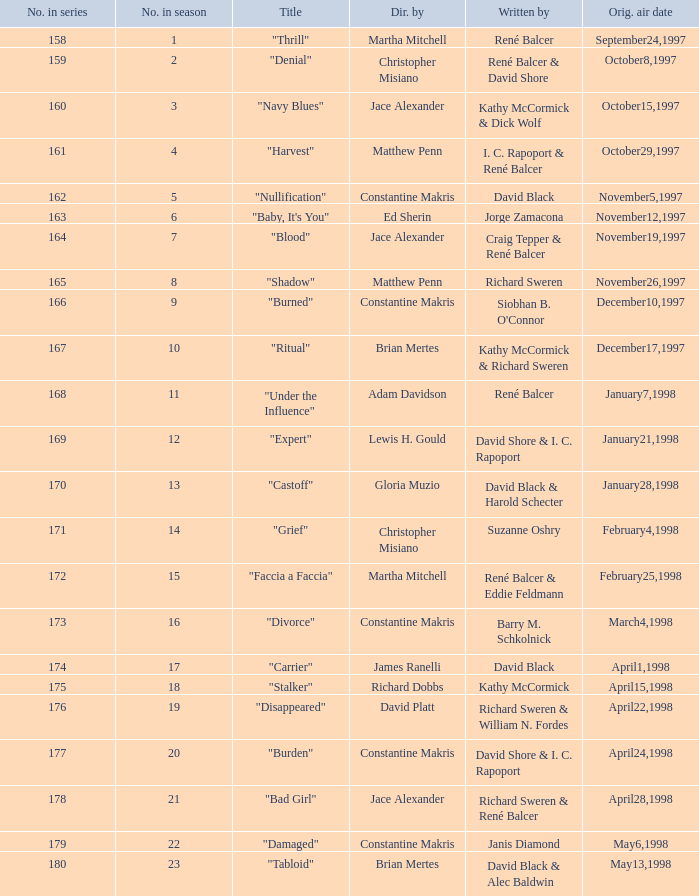What number did the series assign to this season's first episode? 158.0. 